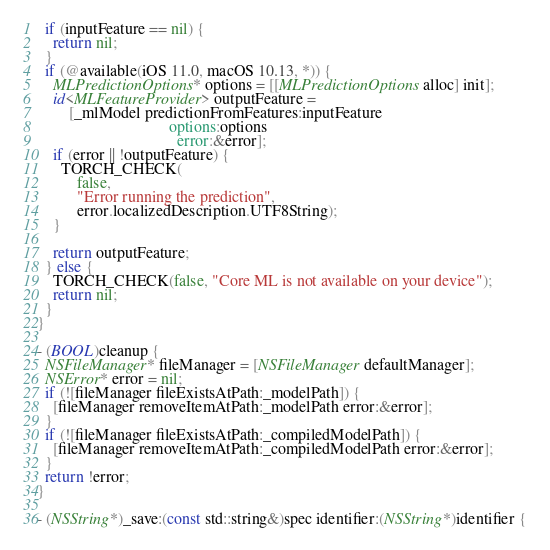Convert code to text. <code><loc_0><loc_0><loc_500><loc_500><_ObjectiveC_>  if (inputFeature == nil) {
    return nil;
  }
  if (@available(iOS 11.0, macOS 10.13, *)) {
    MLPredictionOptions* options = [[MLPredictionOptions alloc] init];
    id<MLFeatureProvider> outputFeature =
        [_mlModel predictionFromFeatures:inputFeature
                                 options:options
                                   error:&error];
    if (error || !outputFeature) {
      TORCH_CHECK(
          false,
          "Error running the prediction",
          error.localizedDescription.UTF8String);
    }

    return outputFeature;
  } else {
    TORCH_CHECK(false, "Core ML is not available on your device");
    return nil;
  }
}

- (BOOL)cleanup {
  NSFileManager* fileManager = [NSFileManager defaultManager];
  NSError* error = nil;
  if (![fileManager fileExistsAtPath:_modelPath]) {
    [fileManager removeItemAtPath:_modelPath error:&error];
  }
  if (![fileManager fileExistsAtPath:_compiledModelPath]) {
    [fileManager removeItemAtPath:_compiledModelPath error:&error];
  }
  return !error;
}

- (NSString*)_save:(const std::string&)spec identifier:(NSString*)identifier {</code> 